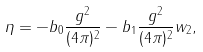<formula> <loc_0><loc_0><loc_500><loc_500>\eta = - b _ { 0 } \frac { g ^ { 2 } } { ( 4 \pi ) ^ { 2 } } - b _ { 1 } \frac { g ^ { 2 } } { ( 4 \pi ) ^ { 2 } } w _ { 2 } ,</formula> 